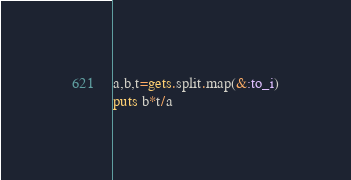<code> <loc_0><loc_0><loc_500><loc_500><_Ruby_>a,b,t=gets.split.map(&:to_i)
puts b*t/a</code> 